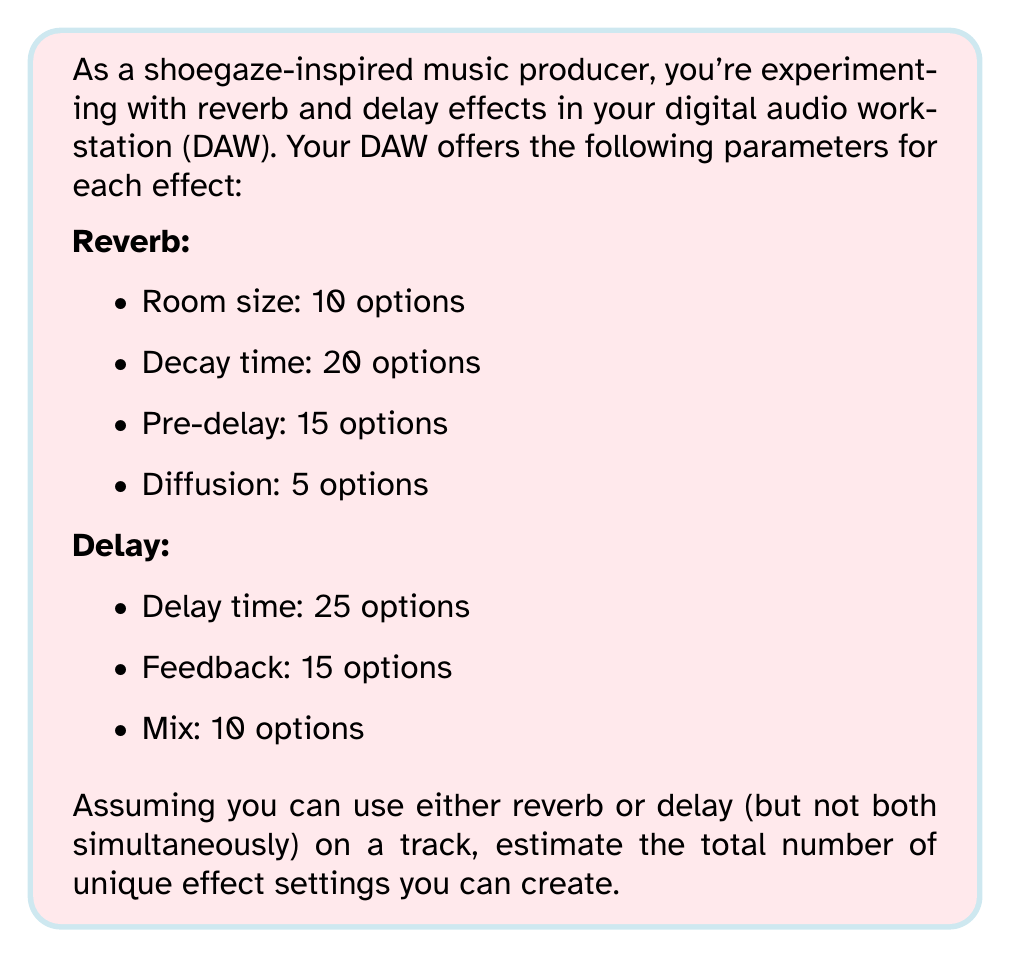Can you answer this question? To solve this problem, we'll use the multiplication principle of counting and then add the results for reverb and delay.

1. For reverb:
   The total number of unique reverb settings is the product of all its parameter options:
   $$ \text{Reverb combinations} = 10 \times 20 \times 15 \times 5 = 15,000 $$

2. For delay:
   Similarly, the total number of unique delay settings is:
   $$ \text{Delay combinations} = 25 \times 15 \times 10 = 3,750 $$

3. Total unique settings:
   Since we can use either reverb or delay (but not both), we add these results:
   $$ \text{Total unique settings} = 15,000 + 3,750 = 18,750 $$

This gives us the exact number of unique settings. However, as the question asks for an estimate, we can round this to 19,000 for a more manageable figure.
Answer: Approximately 19,000 unique effect settings 